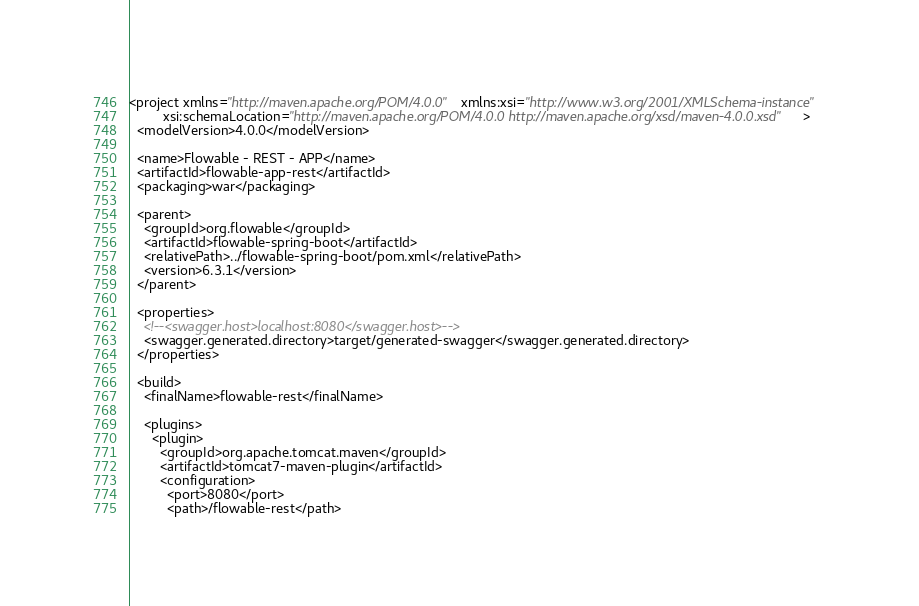Convert code to text. <code><loc_0><loc_0><loc_500><loc_500><_XML_><project xmlns="http://maven.apache.org/POM/4.0.0" xmlns:xsi="http://www.w3.org/2001/XMLSchema-instance"
         xsi:schemaLocation="http://maven.apache.org/POM/4.0.0 http://maven.apache.org/xsd/maven-4.0.0.xsd">
  <modelVersion>4.0.0</modelVersion>

  <name>Flowable - REST - APP</name>
  <artifactId>flowable-app-rest</artifactId>
  <packaging>war</packaging>

  <parent>
    <groupId>org.flowable</groupId>
    <artifactId>flowable-spring-boot</artifactId>
    <relativePath>../flowable-spring-boot/pom.xml</relativePath>
    <version>6.3.1</version>
  </parent>

  <properties>
    <!--<swagger.host>localhost:8080</swagger.host>-->
    <swagger.generated.directory>target/generated-swagger</swagger.generated.directory>
  </properties>

  <build>
    <finalName>flowable-rest</finalName>

    <plugins>
      <plugin>
	    <groupId>org.apache.tomcat.maven</groupId>
        <artifactId>tomcat7-maven-plugin</artifactId>
		<configuration>
		  <port>8080</port>
		  <path>/flowable-rest</path></code> 